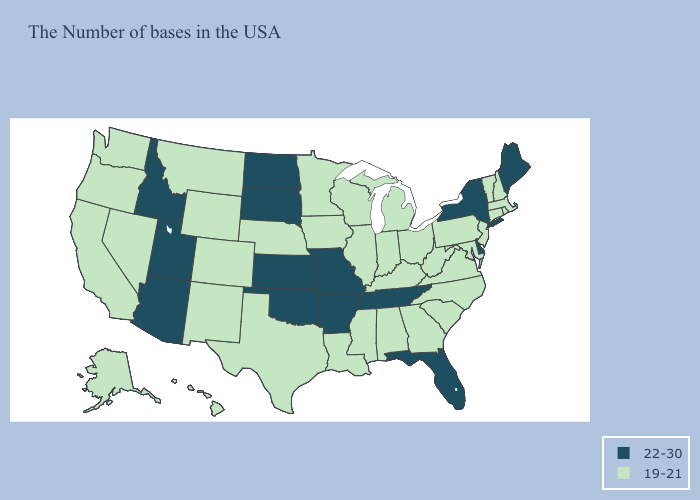What is the value of Georgia?
Concise answer only. 19-21. What is the highest value in the South ?
Short answer required. 22-30. What is the lowest value in states that border South Carolina?
Write a very short answer. 19-21. What is the highest value in the South ?
Answer briefly. 22-30. Among the states that border Colorado , which have the lowest value?
Answer briefly. Nebraska, Wyoming, New Mexico. What is the value of Massachusetts?
Write a very short answer. 19-21. What is the highest value in the Northeast ?
Keep it brief. 22-30. What is the value of Maryland?
Quick response, please. 19-21. What is the value of Kansas?
Keep it brief. 22-30. Does Arkansas have the highest value in the USA?
Give a very brief answer. Yes. What is the value of California?
Short answer required. 19-21. Among the states that border Tennessee , does Missouri have the lowest value?
Answer briefly. No. Name the states that have a value in the range 19-21?
Be succinct. Massachusetts, Rhode Island, New Hampshire, Vermont, Connecticut, New Jersey, Maryland, Pennsylvania, Virginia, North Carolina, South Carolina, West Virginia, Ohio, Georgia, Michigan, Kentucky, Indiana, Alabama, Wisconsin, Illinois, Mississippi, Louisiana, Minnesota, Iowa, Nebraska, Texas, Wyoming, Colorado, New Mexico, Montana, Nevada, California, Washington, Oregon, Alaska, Hawaii. What is the lowest value in the USA?
Quick response, please. 19-21. 